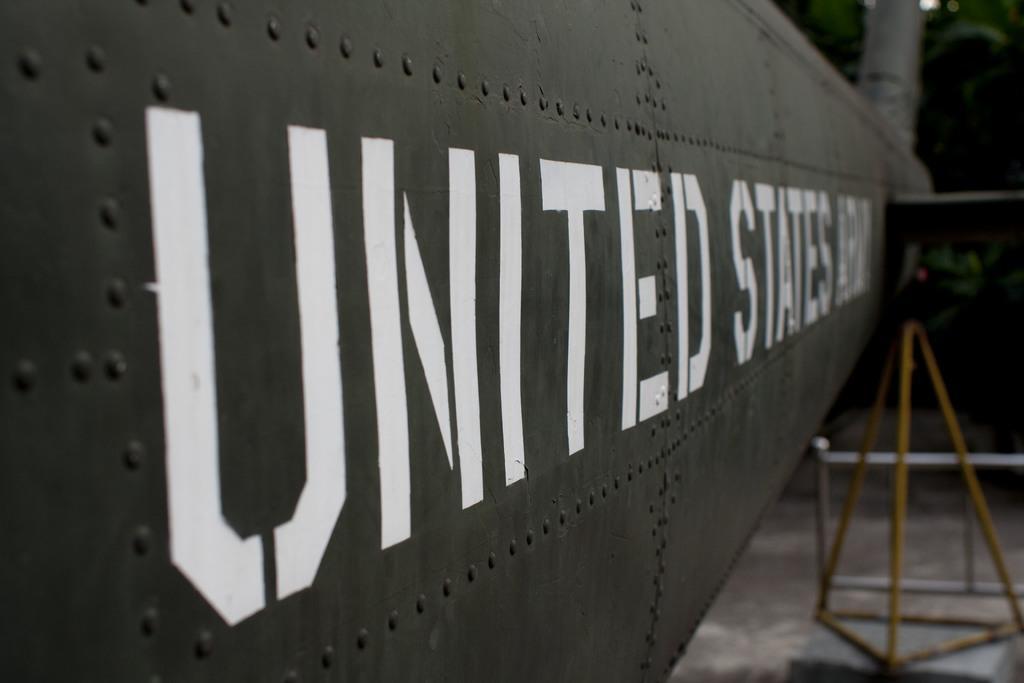Please provide a concise description of this image. In this picture we can see text on the metal door, in the background we can see a stand. 